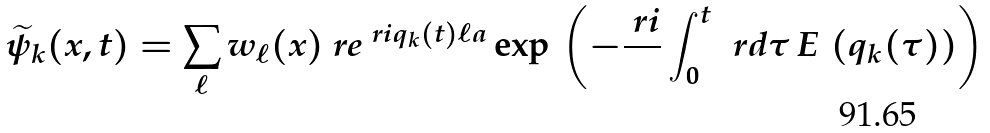Convert formula to latex. <formula><loc_0><loc_0><loc_500><loc_500>\widetilde { \psi } _ { k } ( x , t ) = \sum _ { \ell } w _ { \ell } ( x ) \ r e ^ { \ r i q _ { k } ( t ) \ell a } \exp \, \left ( - \frac { \ r i } { } \int _ { 0 } ^ { t } \, \ r d \tau \, E \, \left ( q _ { k } ( \tau ) \right ) \right )</formula> 